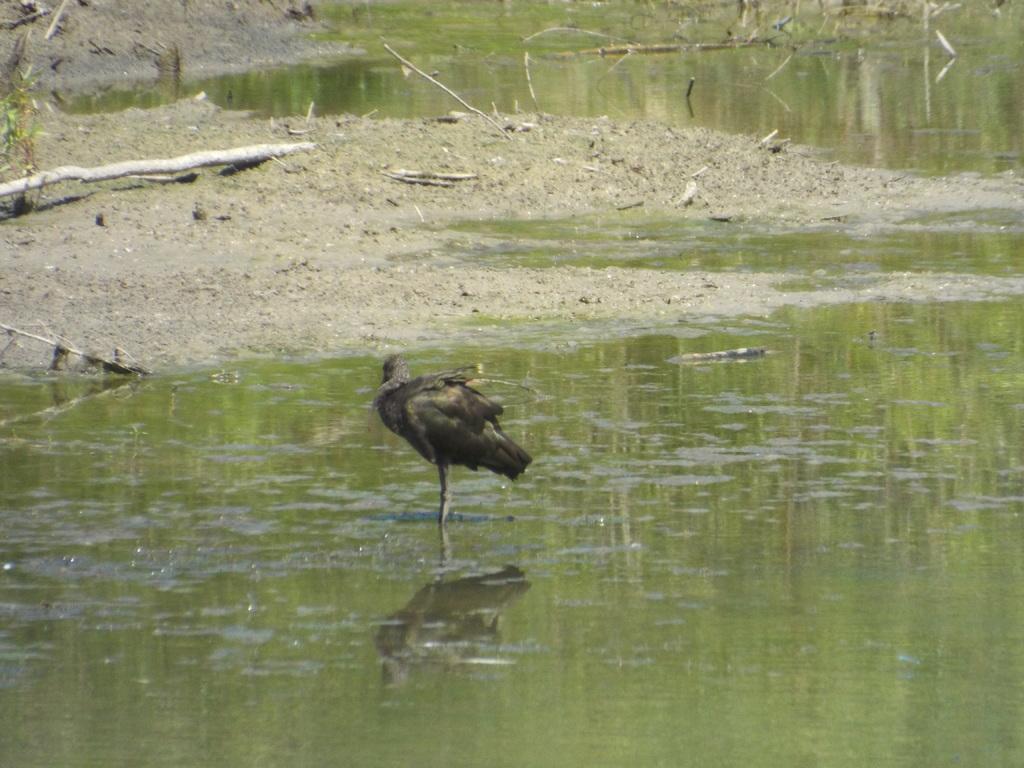How would you summarize this image in a sentence or two? In the center of the image we can see duck in the water. In the background we can see water and mud. 